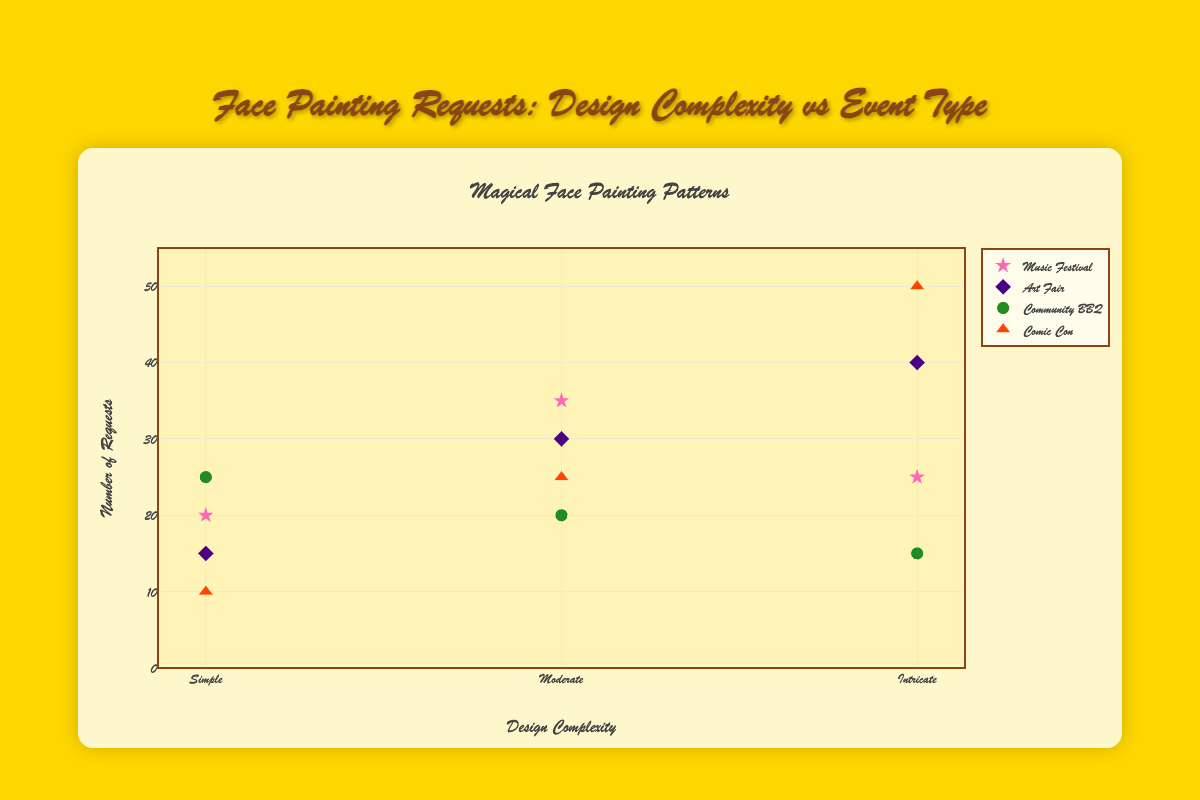What is the title of the plot? The title of the plot is displayed at the top and provides an overview of the data presented. It reads "Magical Face Painting Patterns".
Answer: Magical Face Painting Patterns Which event had the highest number of requests for Intricate designs? To find the event with the highest number of requests for Intricate designs, look at the y-values for the 'Intricate' x-category. The event with the highest y-value is 'Comic Con' with 50 requests.
Answer: Comic Con How many requests were made for Simple designs at Community BBQs? Locate the 'Community BBQ' data series and find the y-value corresponding to the 'Simple' x-category. The plot shows 25 requests.
Answer: 25 Compare the number of requests for Moderate designs at Music Festivals and Art Fairs. Which one is higher? Compare the 'Moderate' design complexity y-values for Music Festivals and Art Fairs. Music Festivals have 35 requests, whereas Art Fairs have 30 requests. Music Festivals have more.
Answer: Music Festivals What is the sum of requests for Moderate designs across all event types? Add the y-values for 'Moderate' designs from all events: Music Festival (35), Art Fair (30), Community BBQ (20), Comic Con (25). Sum: 35 + 30 + 20 + 25 = 110
Answer: 110 What is the difference in the number of requests for Intricate designs between Art Fairs and Comic Cons? Find the y-values for 'Intricate' designs for both Art Fair (40) and Comic Con (50). Calculate the difference: 50 - 40 = 10
Answer: 10 Which event type had the lowest number of requests for Simple designs? Look at the 'Simple' design category and compare all event types. 'Comic Con' has the lowest number with 10 requests.
Answer: Comic Con How do the requests for Moderate designs at Community BBQs compare to requests for Intricate designs at the same event? Compare the y-values for 'Moderate' (20) and 'Intricate' (15) designs at Community BBQs. Moderate has more requests.
Answer: Moderate has more What is the average number of requests for Simple designs across all event types? Add the y-values for 'Simple' designs from all events and divide by the number of events: (20 + 15 + 25 + 10) / 4 = 70 / 4 = 17.5
Answer: 17.5 Which design complexity has the highest overall number of requests? Add the y-values for each design complexity across all events: Simple (20 + 15 + 25 + 10 = 70), Moderate (35 + 30 + 20 + 25 = 110), Intricate (25 + 40 + 15 + 50 = 130). 'Intricate' has the highest overall requests with 130.
Answer: Intricate 